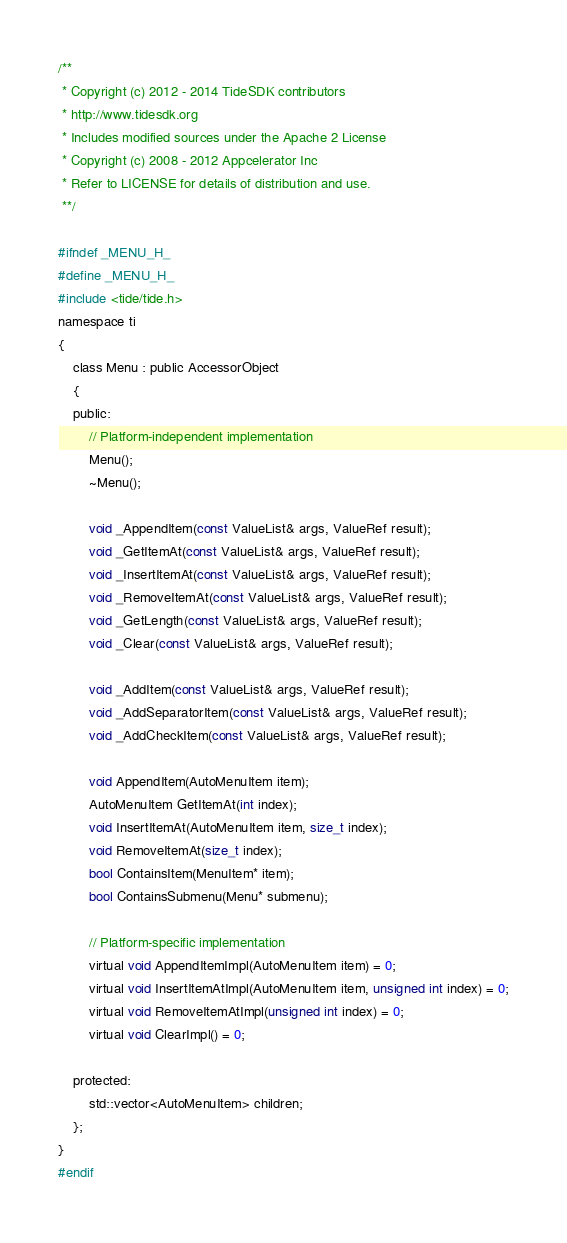Convert code to text. <code><loc_0><loc_0><loc_500><loc_500><_C_>/**
 * Copyright (c) 2012 - 2014 TideSDK contributors
 * http://www.tidesdk.org
 * Includes modified sources under the Apache 2 License
 * Copyright (c) 2008 - 2012 Appcelerator Inc
 * Refer to LICENSE for details of distribution and use.
 **/

#ifndef _MENU_H_
#define _MENU_H_
#include <tide/tide.h>
namespace ti
{
    class Menu : public AccessorObject
    {
    public:
        // Platform-independent implementation
        Menu();
        ~Menu();

        void _AppendItem(const ValueList& args, ValueRef result);
        void _GetItemAt(const ValueList& args, ValueRef result);
        void _InsertItemAt(const ValueList& args, ValueRef result);
        void _RemoveItemAt(const ValueList& args, ValueRef result);
        void _GetLength(const ValueList& args, ValueRef result);
        void _Clear(const ValueList& args, ValueRef result);

        void _AddItem(const ValueList& args, ValueRef result);
        void _AddSeparatorItem(const ValueList& args, ValueRef result);
        void _AddCheckItem(const ValueList& args, ValueRef result);

        void AppendItem(AutoMenuItem item);
        AutoMenuItem GetItemAt(int index);
        void InsertItemAt(AutoMenuItem item, size_t index);
        void RemoveItemAt(size_t index);
        bool ContainsItem(MenuItem* item);
        bool ContainsSubmenu(Menu* submenu);

        // Platform-specific implementation
        virtual void AppendItemImpl(AutoMenuItem item) = 0;
        virtual void InsertItemAtImpl(AutoMenuItem item, unsigned int index) = 0;
        virtual void RemoveItemAtImpl(unsigned int index) = 0;
        virtual void ClearImpl() = 0;

    protected:
        std::vector<AutoMenuItem> children;
    };
}
#endif
</code> 